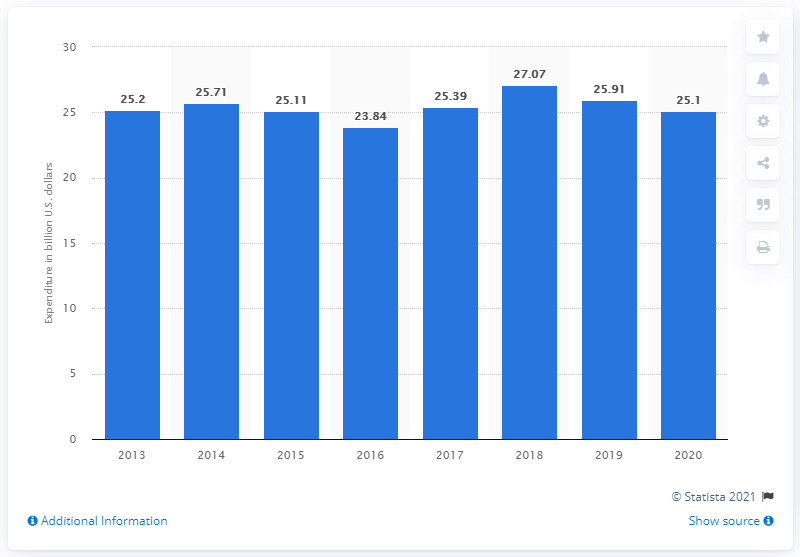Indicate a few pertinent items in this graphic. Brazil's highest military budget was recorded in 2018. In 2018, Brazil's military budget was approximately 27.07. Brazil spent approximately 25.1 billion US dollars on the military in 2020. 